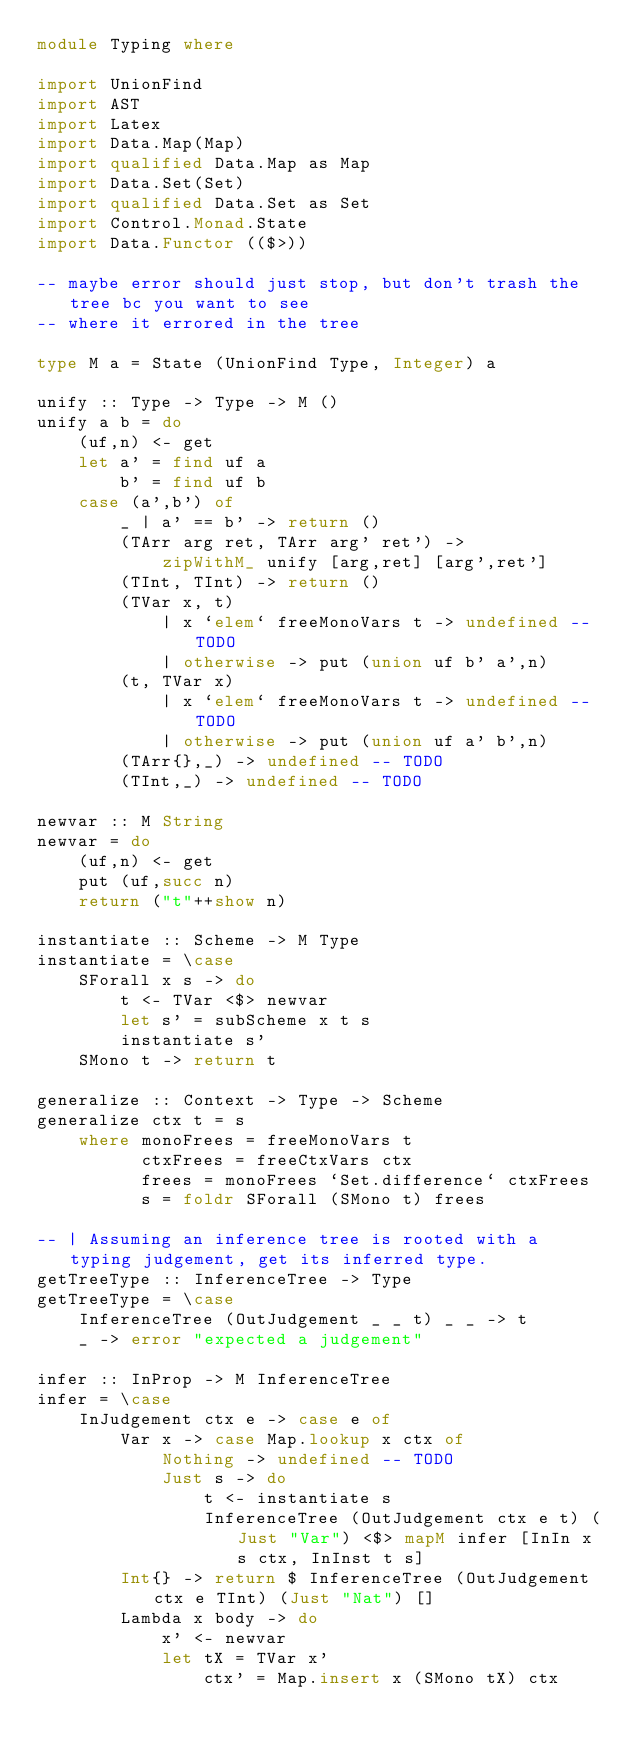<code> <loc_0><loc_0><loc_500><loc_500><_Haskell_>module Typing where

import UnionFind
import AST
import Latex
import Data.Map(Map)
import qualified Data.Map as Map
import Data.Set(Set)
import qualified Data.Set as Set
import Control.Monad.State
import Data.Functor (($>))

-- maybe error should just stop, but don't trash the tree bc you want to see
-- where it errored in the tree

type M a = State (UnionFind Type, Integer) a

unify :: Type -> Type -> M ()
unify a b = do
    (uf,n) <- get
    let a' = find uf a
        b' = find uf b
    case (a',b') of
        _ | a' == b' -> return ()
        (TArr arg ret, TArr arg' ret') ->
            zipWithM_ unify [arg,ret] [arg',ret']
        (TInt, TInt) -> return ()
        (TVar x, t)
            | x `elem` freeMonoVars t -> undefined -- TODO
            | otherwise -> put (union uf b' a',n)
        (t, TVar x)
            | x `elem` freeMonoVars t -> undefined -- TODO
            | otherwise -> put (union uf a' b',n)
        (TArr{},_) -> undefined -- TODO
        (TInt,_) -> undefined -- TODO

newvar :: M String
newvar = do
    (uf,n) <- get
    put (uf,succ n)
    return ("t"++show n)

instantiate :: Scheme -> M Type
instantiate = \case
    SForall x s -> do
        t <- TVar <$> newvar
        let s' = subScheme x t s
        instantiate s'
    SMono t -> return t

generalize :: Context -> Type -> Scheme
generalize ctx t = s
    where monoFrees = freeMonoVars t
          ctxFrees = freeCtxVars ctx
          frees = monoFrees `Set.difference` ctxFrees
          s = foldr SForall (SMono t) frees

-- | Assuming an inference tree is rooted with a typing judgement, get its inferred type.
getTreeType :: InferenceTree -> Type
getTreeType = \case
    InferenceTree (OutJudgement _ _ t) _ _ -> t
    _ -> error "expected a judgement"

infer :: InProp -> M InferenceTree
infer = \case
    InJudgement ctx e -> case e of
        Var x -> case Map.lookup x ctx of
            Nothing -> undefined -- TODO
            Just s -> do
                t <- instantiate s
                InferenceTree (OutJudgement ctx e t) (Just "Var") <$> mapM infer [InIn x s ctx, InInst t s]
        Int{} -> return $ InferenceTree (OutJudgement ctx e TInt) (Just "Nat") []
        Lambda x body -> do
            x' <- newvar
            let tX = TVar x'
                ctx' = Map.insert x (SMono tX) ctx</code> 